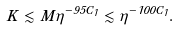<formula> <loc_0><loc_0><loc_500><loc_500>K \lesssim M \eta ^ { - 9 5 C _ { 1 } } \lesssim \eta ^ { - 1 0 0 C _ { 1 } } .</formula> 